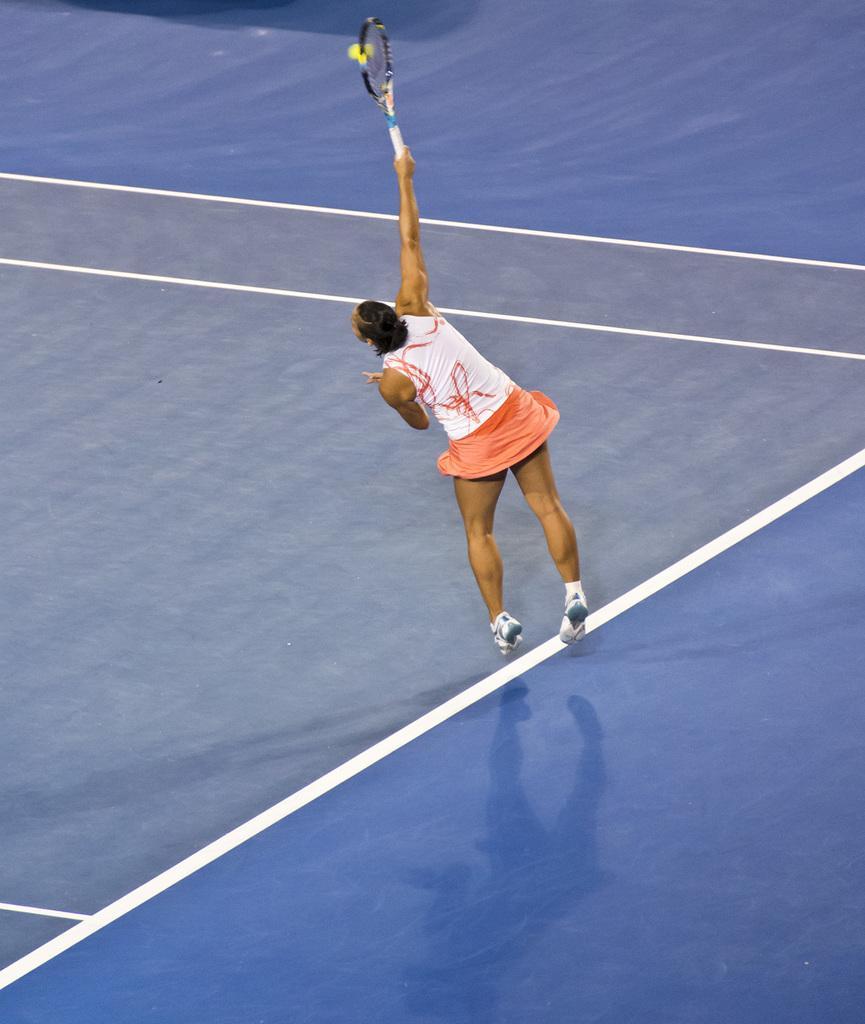How would you summarize this image in a sentence or two? This image is taken in a tennis court. At the bottom of the image there is a floor. In the middle of the image a woman is playing tennis with a tennis bat and ball. 